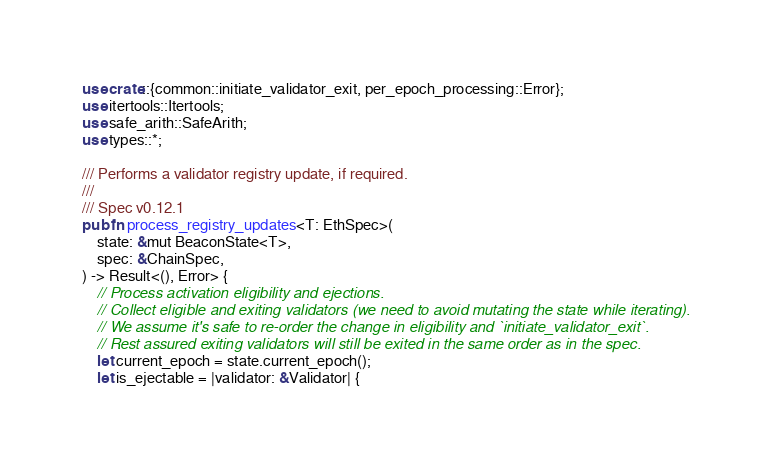Convert code to text. <code><loc_0><loc_0><loc_500><loc_500><_Rust_>use crate::{common::initiate_validator_exit, per_epoch_processing::Error};
use itertools::Itertools;
use safe_arith::SafeArith;
use types::*;

/// Performs a validator registry update, if required.
///
/// Spec v0.12.1
pub fn process_registry_updates<T: EthSpec>(
    state: &mut BeaconState<T>,
    spec: &ChainSpec,
) -> Result<(), Error> {
    // Process activation eligibility and ejections.
    // Collect eligible and exiting validators (we need to avoid mutating the state while iterating).
    // We assume it's safe to re-order the change in eligibility and `initiate_validator_exit`.
    // Rest assured exiting validators will still be exited in the same order as in the spec.
    let current_epoch = state.current_epoch();
    let is_ejectable = |validator: &Validator| {</code> 